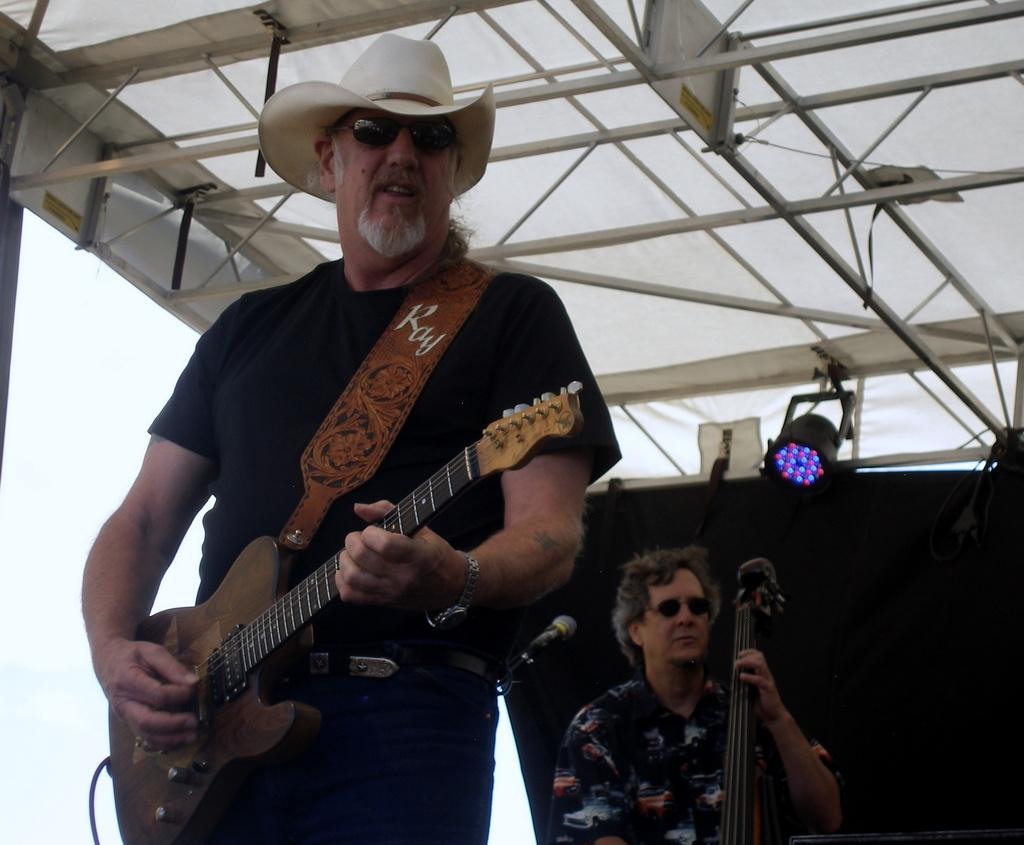How many people are in the image? There are two people in the image. What are the people doing in the image? Both people are holding musical instruments. Can you describe the clothing or accessories of one of the people? One person is wearing a hat. How many bikes are parked next to the people in the image? There are no bikes present in the image. What type of nose does the representative in the image have? There is no representative present in the image, and therefore no nose can be described. 